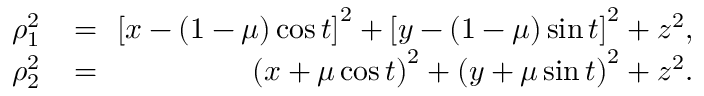Convert formula to latex. <formula><loc_0><loc_0><loc_500><loc_500>\begin{array} { r l r } { \quad \rho _ { 1 } ^ { 2 } } & \, = \, } & { { \left [ x - ( 1 - \mu ) \cos { t } \right ] } ^ { 2 } + { \left [ y - ( 1 - \mu ) \sin { t } \right ] } ^ { 2 } + z ^ { 2 } , } \\ { \quad \rho _ { 2 } ^ { 2 } } & \, = \, } & { { \left ( x + \mu \cos { t } \right ) } ^ { 2 } + { \left ( y + \mu \sin { t } \right ) } ^ { 2 } + z ^ { 2 } . } \end{array}</formula> 